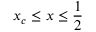Convert formula to latex. <formula><loc_0><loc_0><loc_500><loc_500>x _ { c } \leq x \leq \frac { 1 } { 2 }</formula> 